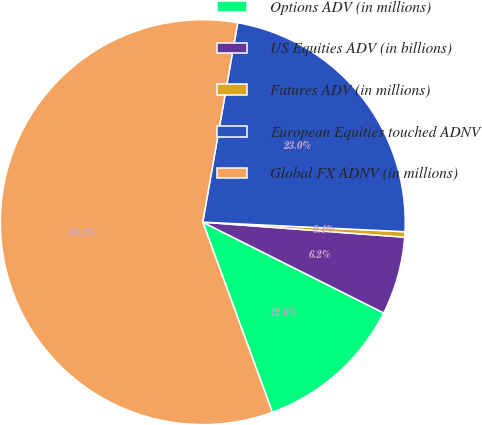Convert chart to OTSL. <chart><loc_0><loc_0><loc_500><loc_500><pie_chart><fcel>Options ADV (in millions)<fcel>US Equities ADV (in billions)<fcel>Futures ADV (in millions)<fcel>European Equities touched ADNV<fcel>Global FX ADNV (in millions)<nl><fcel>12.01%<fcel>6.22%<fcel>0.43%<fcel>22.99%<fcel>58.34%<nl></chart> 